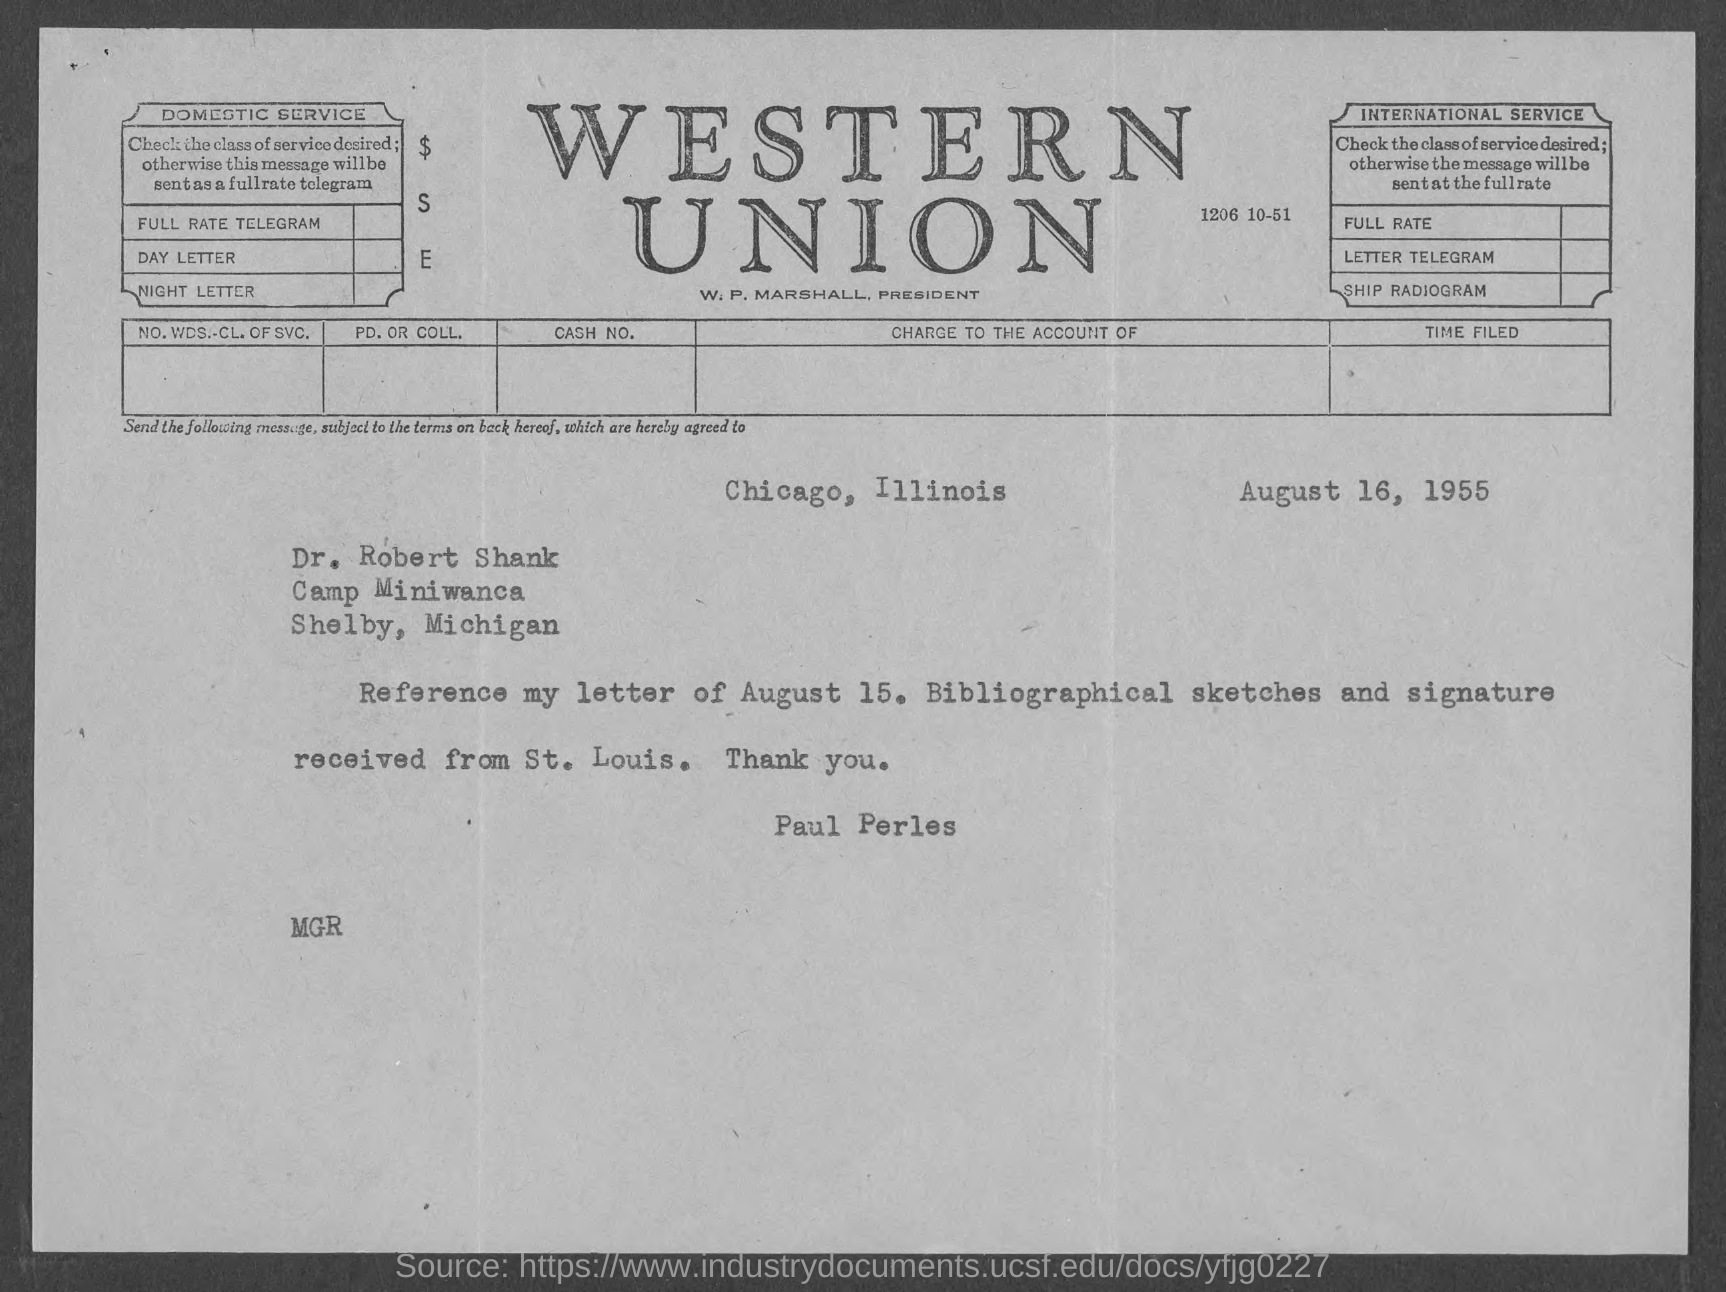When is the document dated?
Provide a short and direct response. August 16, 1955. From which place is the document sent?
Your response must be concise. Chicago, Illinois. Who is the sender?
Keep it short and to the point. Paul Perles. 